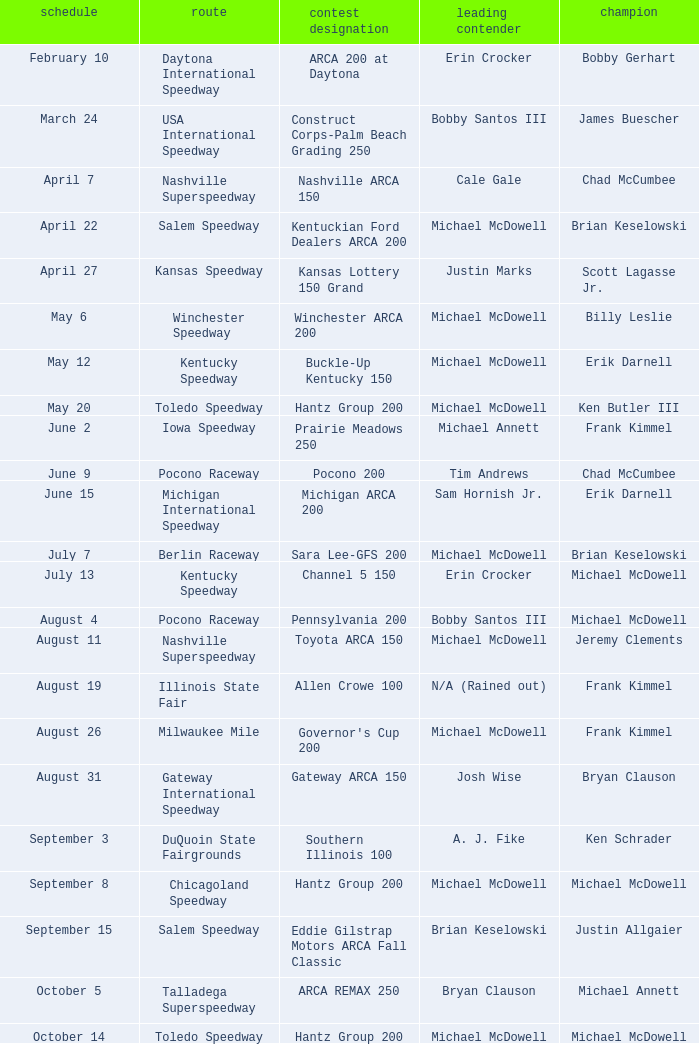Tell me the pole winner of may 12 Michael McDowell. 